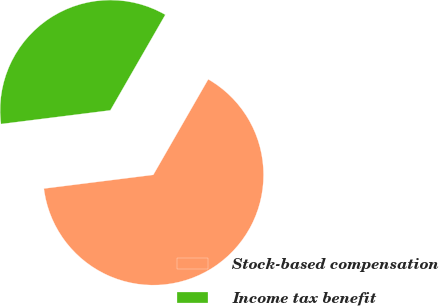<chart> <loc_0><loc_0><loc_500><loc_500><pie_chart><fcel>Stock-based compensation<fcel>Income tax benefit<nl><fcel>64.71%<fcel>35.29%<nl></chart> 